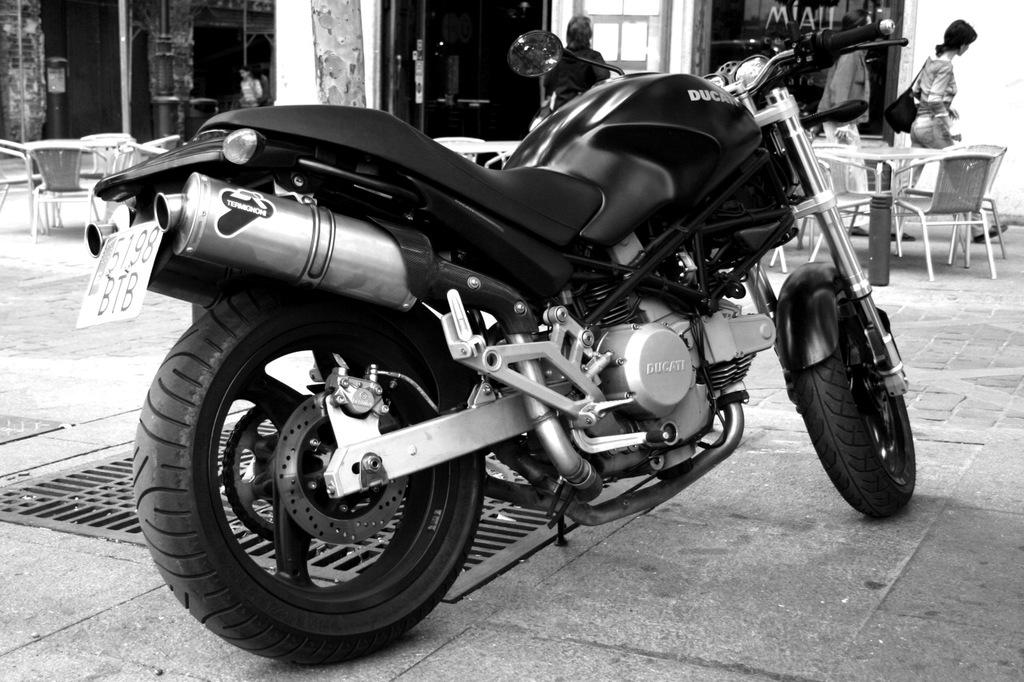What object is placed on the floor in the image? There is a bike on the floor in the image. Are there any other objects or furniture near the bike? Yes, there are chairs near the bike. What is happening in the area with chairs and tables? There are persons walking in the chairs and tables area. What type of mouth can be seen on the bike in the image? There is no mouth present on the bike in the image. What kind of tank is visible in the chairs and tables area? There is no tank present in the chairs and tables area in the image. 